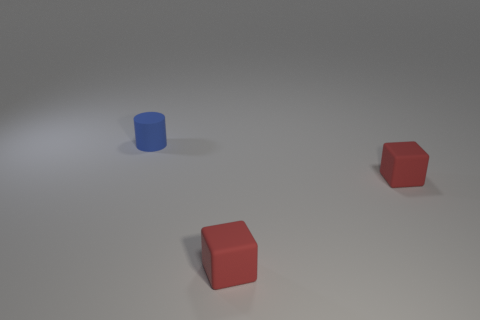The matte cylinder has what color?
Offer a terse response. Blue. How many objects are either blue matte things or rubber cubes?
Give a very brief answer. 3. Is there a tiny red matte object of the same shape as the blue rubber object?
Your answer should be very brief. No. Is there a blue matte thing that has the same size as the blue rubber cylinder?
Your answer should be very brief. No. Are there fewer matte cylinders than rubber objects?
Provide a succinct answer. Yes. What number of things are either objects right of the small cylinder or matte things that are in front of the blue rubber object?
Provide a succinct answer. 2. There is a blue object; are there any red rubber cubes right of it?
Keep it short and to the point. Yes. What number of objects are tiny rubber things that are to the right of the blue matte thing or large purple rubber blocks?
Give a very brief answer. 2. How many cyan things are either matte blocks or shiny things?
Ensure brevity in your answer.  0. What number of other objects are there of the same color as the rubber cylinder?
Make the answer very short. 0. 